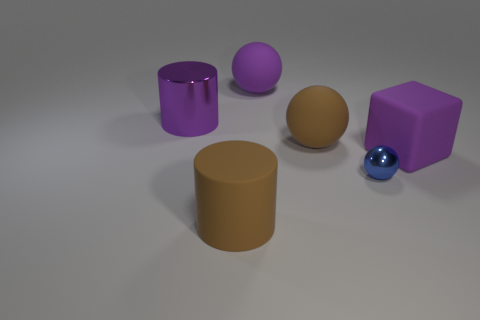What material is the large ball that is the same color as the shiny cylinder?
Give a very brief answer. Rubber. How many brown matte things are the same shape as the purple shiny thing?
Your answer should be very brief. 1. What number of things are balls that are in front of the large rubber cube or purple matte things that are in front of the brown rubber sphere?
Give a very brief answer. 2. The cylinder behind the shiny thing that is on the right side of the large brown rubber cylinder that is left of the purple matte ball is made of what material?
Offer a terse response. Metal. Do the big cylinder behind the big cube and the big matte block have the same color?
Give a very brief answer. Yes. What is the material of the purple thing that is both left of the big purple cube and to the right of the large metal thing?
Your answer should be compact. Rubber. Is there another matte sphere of the same size as the blue ball?
Offer a very short reply. No. How many tiny objects are there?
Make the answer very short. 1. How many purple rubber spheres are right of the purple ball?
Ensure brevity in your answer.  0. Is the material of the tiny ball the same as the brown sphere?
Provide a short and direct response. No. 